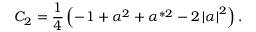Convert formula to latex. <formula><loc_0><loc_0><loc_500><loc_500>C _ { 2 } = \frac { 1 } { 4 } \left ( - 1 + \alpha ^ { 2 } + \alpha ^ { * 2 } - 2 \left | \alpha \right | ^ { 2 } \right ) .</formula> 